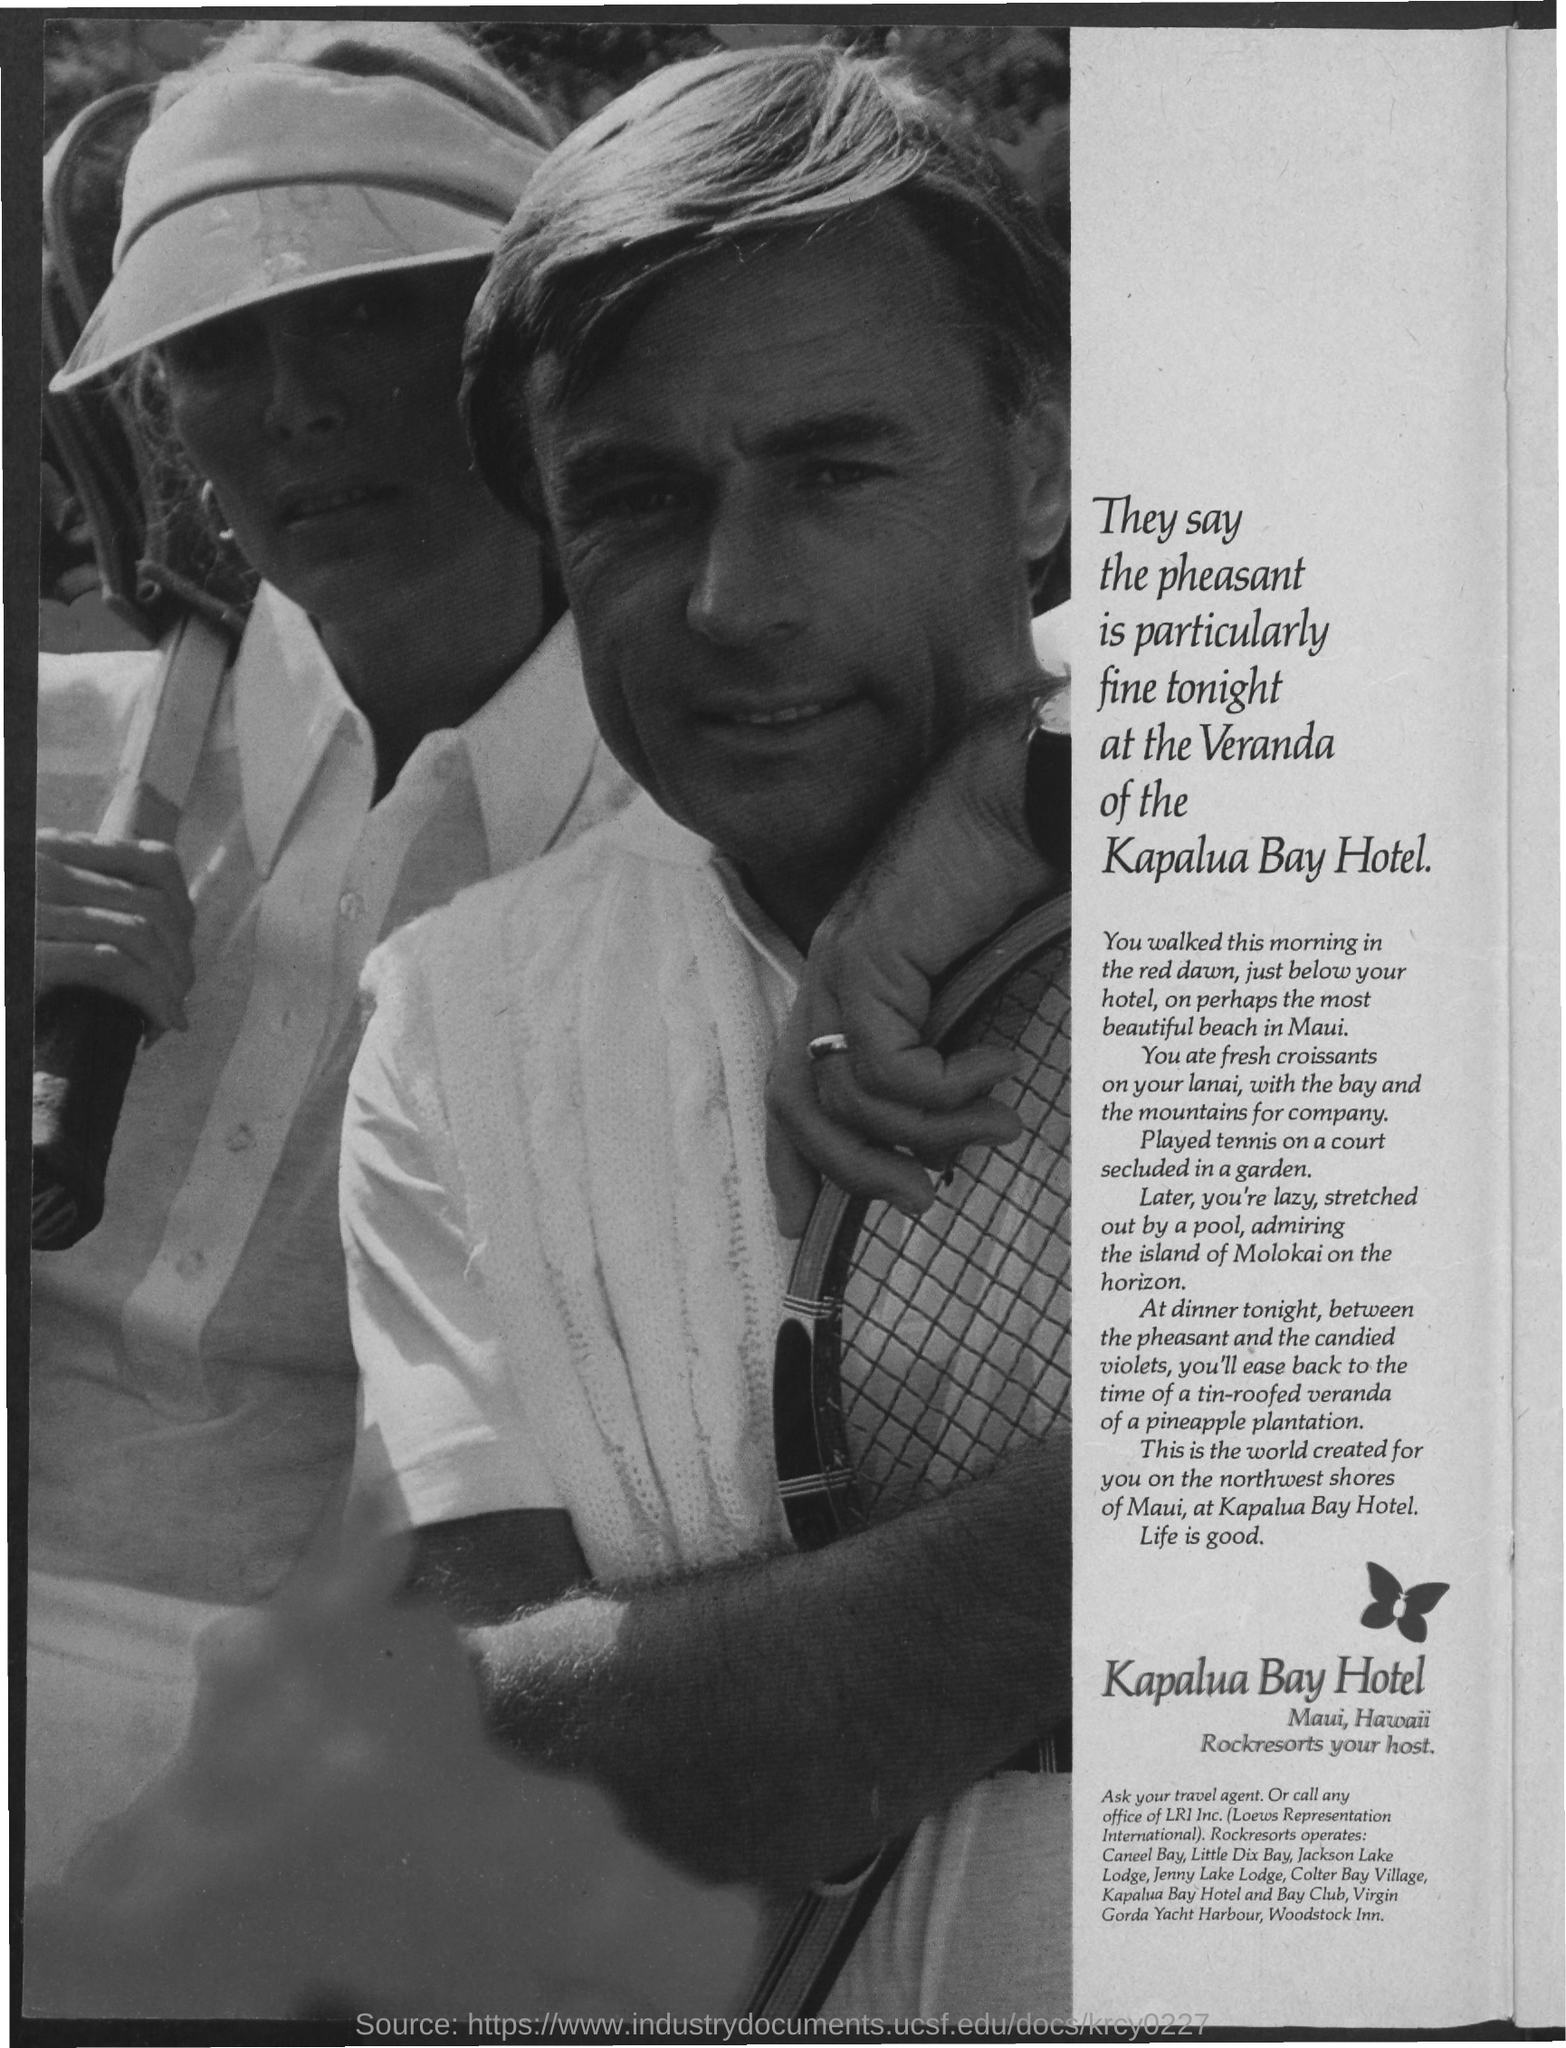Outline some significant characteristics in this image. Kapulua Bay Hotel is located in Maui, Hawaii. 